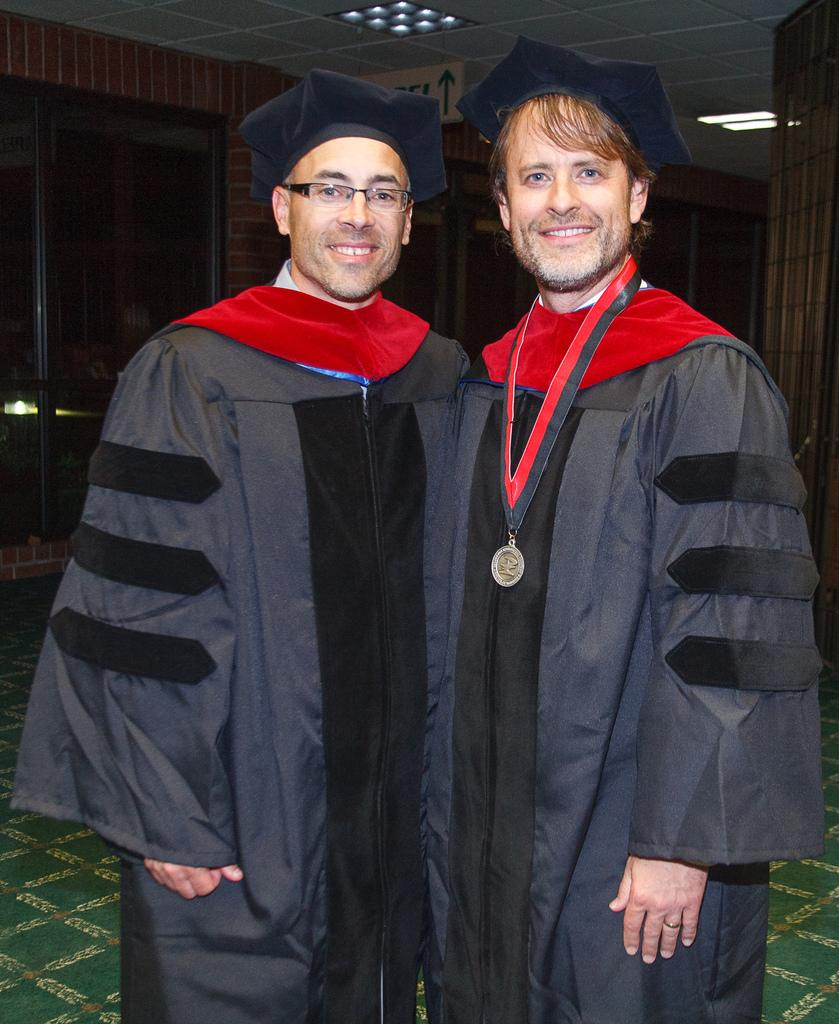How many people are in the image? There are two people in the image. What are the people wearing on their heads? Both people are wearing caps. Can you describe any additional accessories or items worn by one of the people? One person is wearing a medal. What can be seen in the background of the image? There is a roof, a wall, glass doors, lights, and some objects in the background of the image. What type of butter is being spread on the jelly in the image? There is no butter or jelly present in the image; it features two people wearing caps and one of them wearing a medal. 